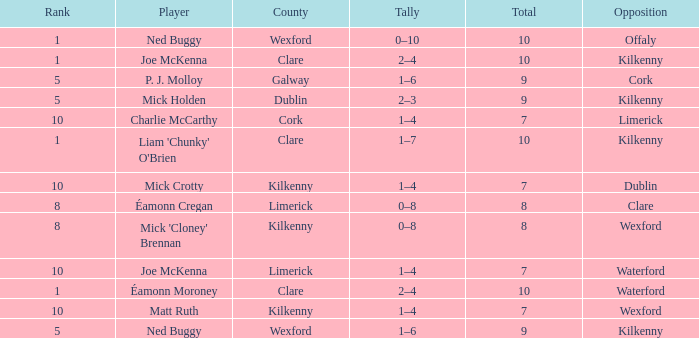Which Total has a County of kilkenny, and a Tally of 1–4, and a Rank larger than 10? None. 